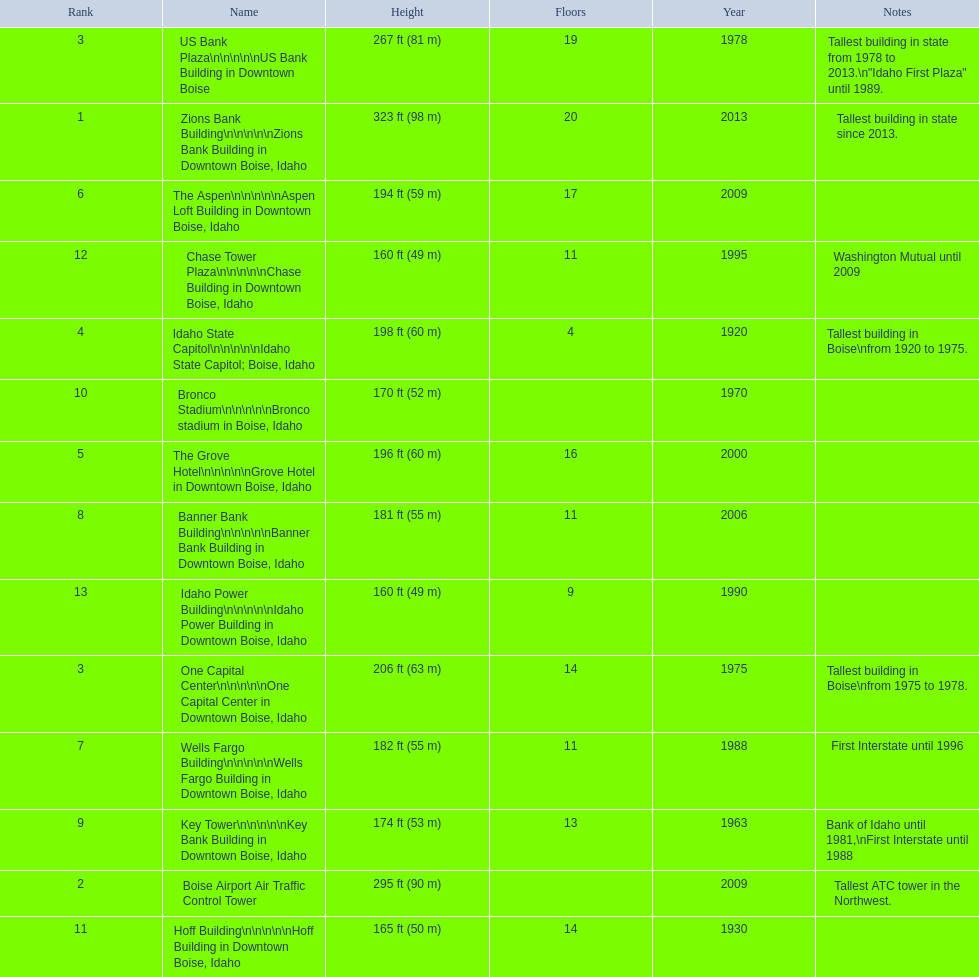What are the number of floors the us bank plaza has? 19. 